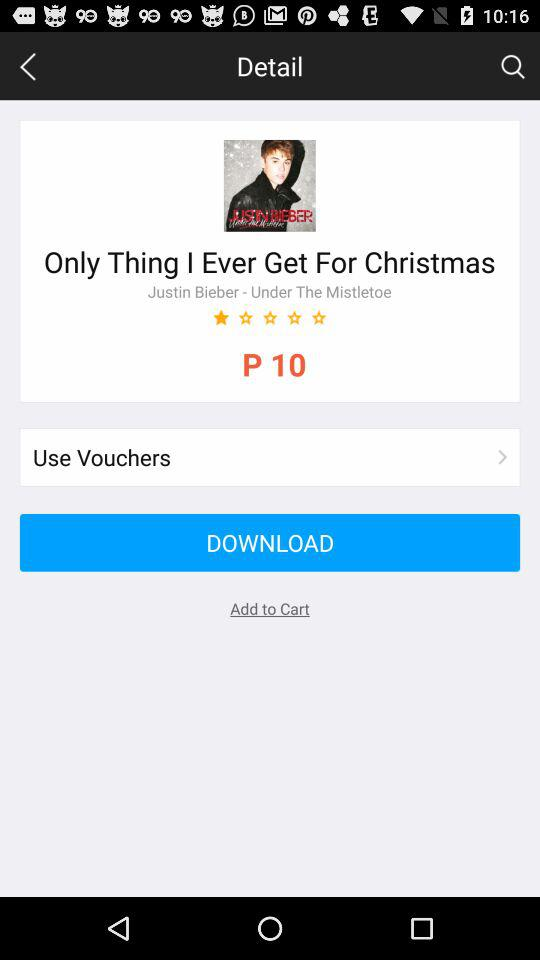Who is the singer of the "Only Thing I Ever Get For Christmas" song? The singer is Justin Bieber. 